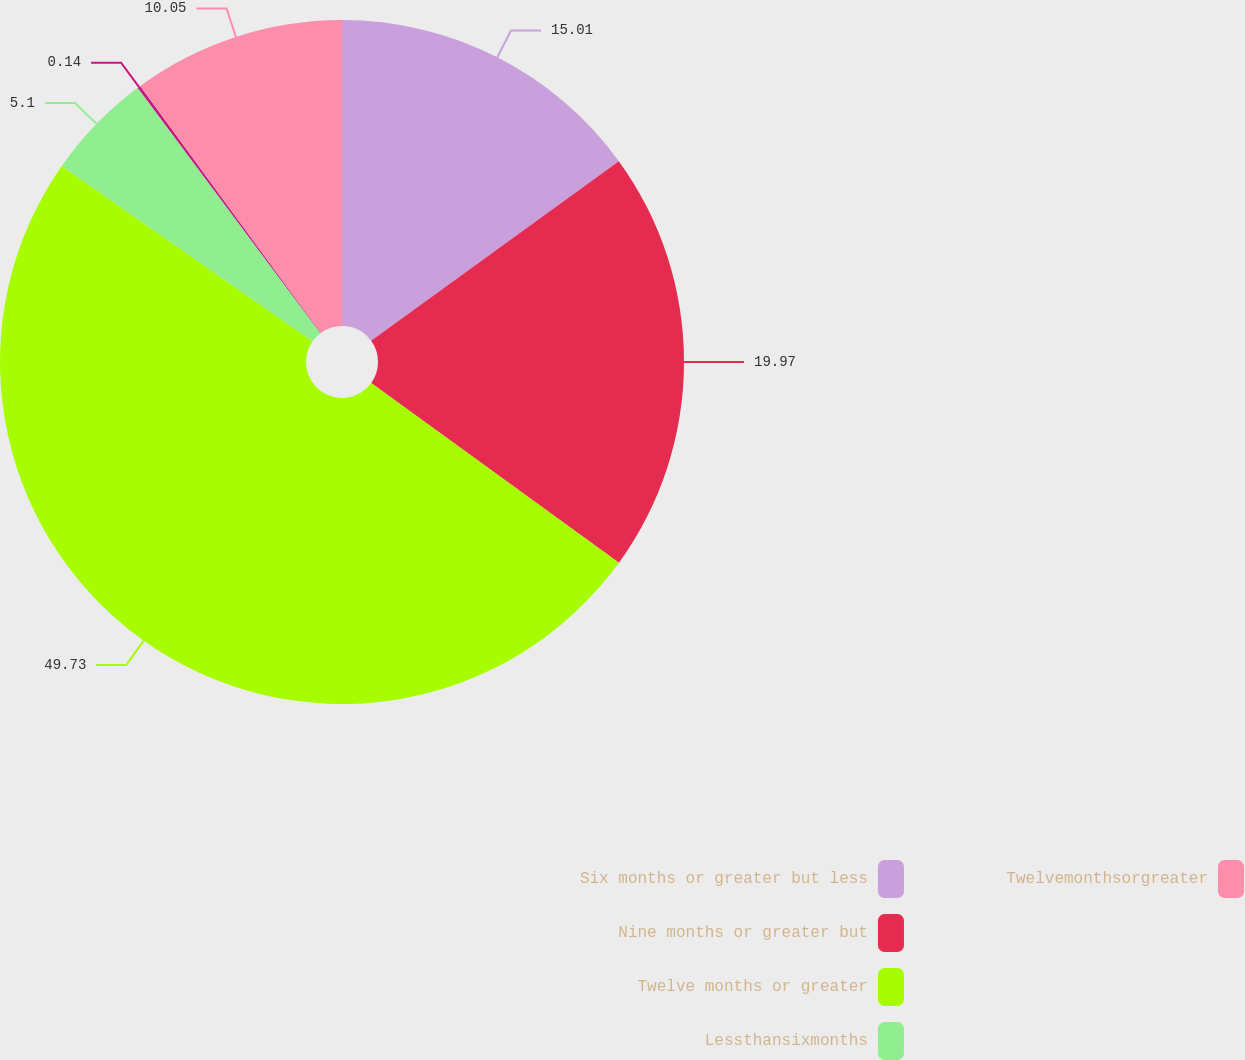Convert chart. <chart><loc_0><loc_0><loc_500><loc_500><pie_chart><fcel>Six months or greater but less<fcel>Nine months or greater but<fcel>Twelve months or greater<fcel>Lessthansixmonths<fcel>Unnamed: 4<fcel>Twelvemonthsorgreater<nl><fcel>15.01%<fcel>19.97%<fcel>49.73%<fcel>5.1%<fcel>0.14%<fcel>10.05%<nl></chart> 